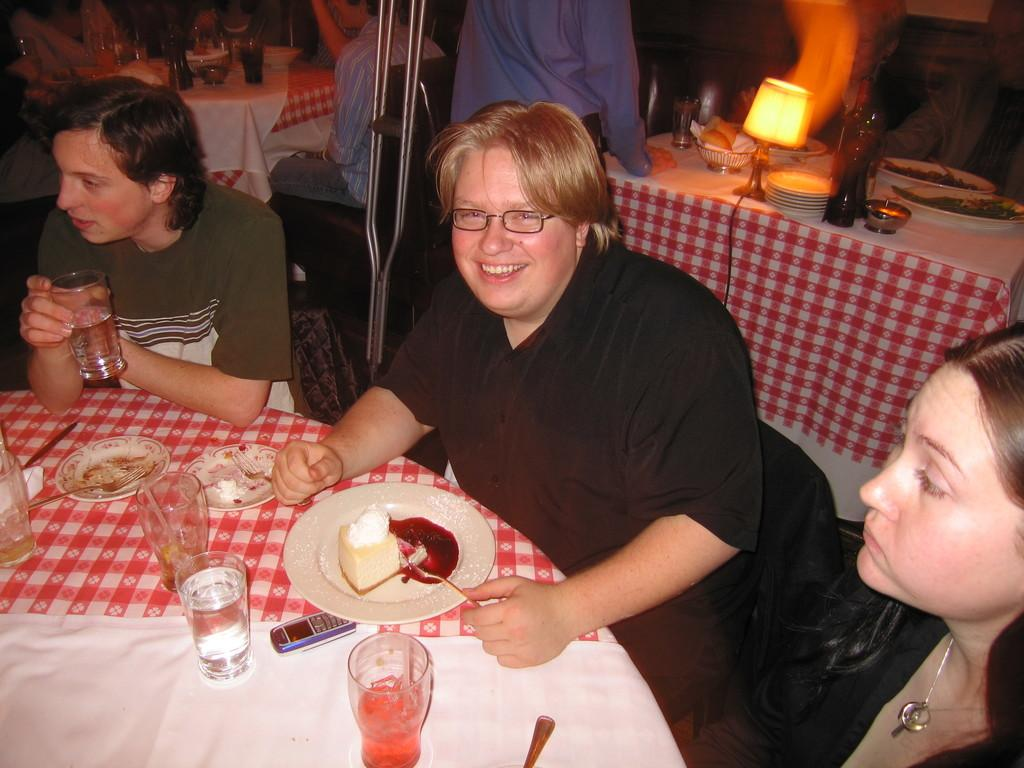What are the people in the image doing? The people in the image are sitting and standing. What piece of furniture is present in the image? There is a table in the image. What is on top of the table? There is a lamp, a plate, a cake piece, glasses, and a fork on the table. Can you see any ghosts interacting with the cake in the image? There are no ghosts present in the image; it only features people, a table, and various objects. 